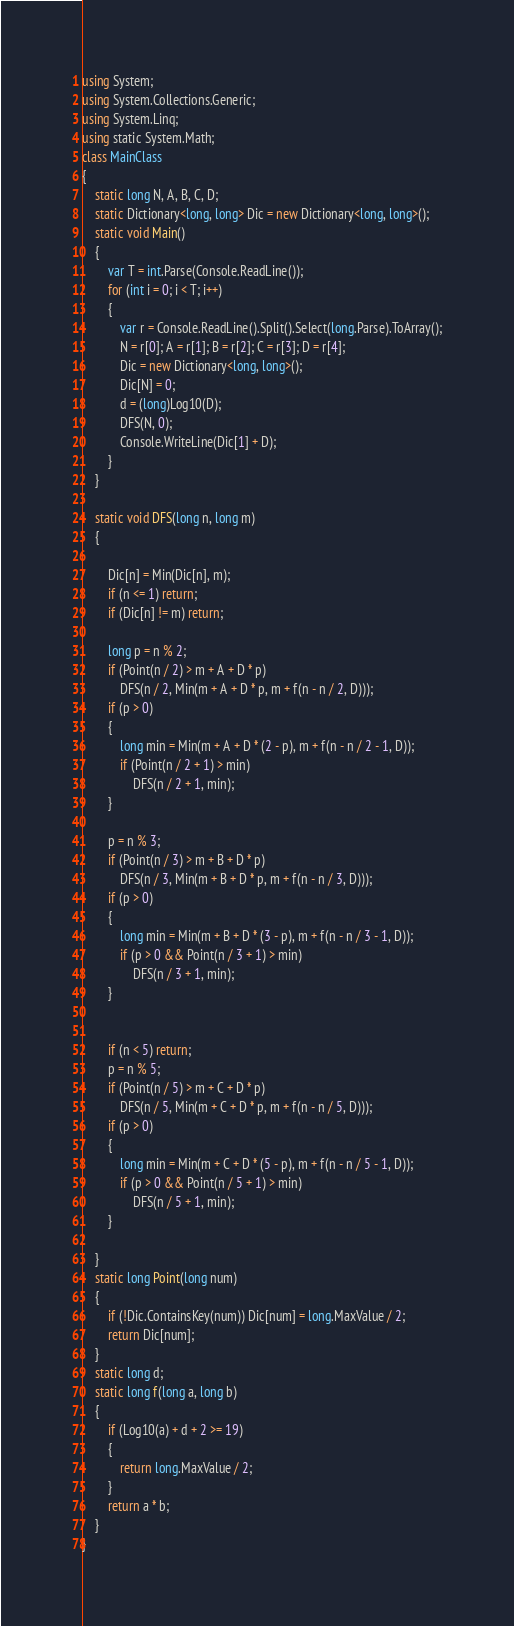Convert code to text. <code><loc_0><loc_0><loc_500><loc_500><_C#_>using System;
using System.Collections.Generic;
using System.Linq;
using static System.Math;
class MainClass
{
    static long N, A, B, C, D;
    static Dictionary<long, long> Dic = new Dictionary<long, long>();
    static void Main()
    {
        var T = int.Parse(Console.ReadLine());
        for (int i = 0; i < T; i++)
        {
            var r = Console.ReadLine().Split().Select(long.Parse).ToArray();
            N = r[0]; A = r[1]; B = r[2]; C = r[3]; D = r[4];
            Dic = new Dictionary<long, long>();
            Dic[N] = 0;
            d = (long)Log10(D);
            DFS(N, 0);
            Console.WriteLine(Dic[1] + D);
        }
    }

    static void DFS(long n, long m)
    {

        Dic[n] = Min(Dic[n], m);
        if (n <= 1) return;
        if (Dic[n] != m) return;

        long p = n % 2;
        if (Point(n / 2) > m + A + D * p)
            DFS(n / 2, Min(m + A + D * p, m + f(n - n / 2, D)));
        if (p > 0)
        {
            long min = Min(m + A + D * (2 - p), m + f(n - n / 2 - 1, D));
            if (Point(n / 2 + 1) > min)
                DFS(n / 2 + 1, min);
        }

        p = n % 3;
        if (Point(n / 3) > m + B + D * p)
            DFS(n / 3, Min(m + B + D * p, m + f(n - n / 3, D)));
        if (p > 0)
        {
            long min = Min(m + B + D * (3 - p), m + f(n - n / 3 - 1, D));
            if (p > 0 && Point(n / 3 + 1) > min)
                DFS(n / 3 + 1, min);
        }


        if (n < 5) return;
        p = n % 5;
        if (Point(n / 5) > m + C + D * p)
            DFS(n / 5, Min(m + C + D * p, m + f(n - n / 5, D)));
        if (p > 0)
        {
            long min = Min(m + C + D * (5 - p), m + f(n - n / 5 - 1, D));
            if (p > 0 && Point(n / 5 + 1) > min)
                DFS(n / 5 + 1, min);
        }

    }
    static long Point(long num)
    {
        if (!Dic.ContainsKey(num)) Dic[num] = long.MaxValue / 2;
        return Dic[num];
    }
    static long d;
    static long f(long a, long b)
    {
        if (Log10(a) + d + 2 >= 19)
        {
            return long.MaxValue / 2;
        }
        return a * b;
    }
}
</code> 